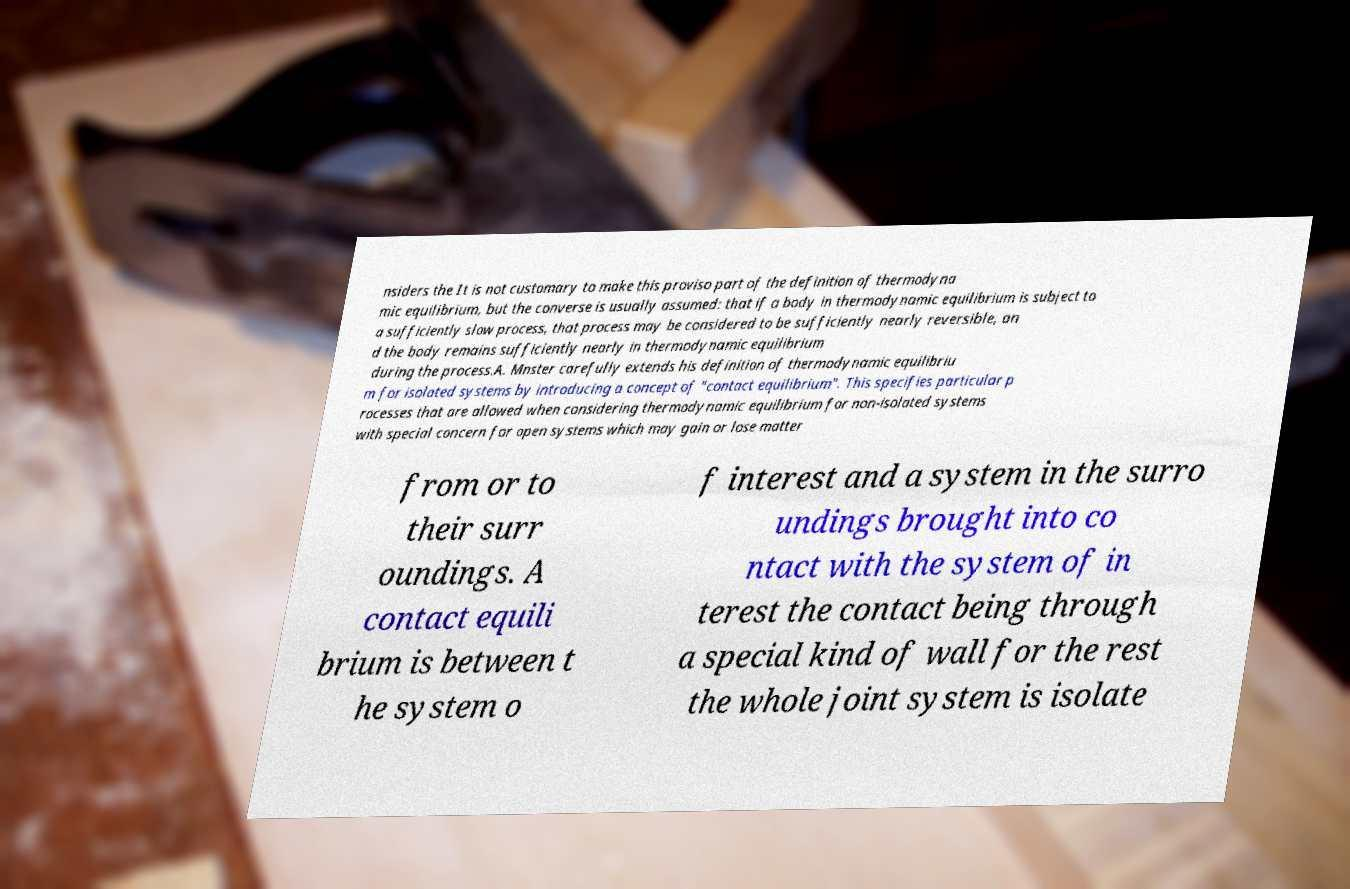There's text embedded in this image that I need extracted. Can you transcribe it verbatim? nsiders the It is not customary to make this proviso part of the definition of thermodyna mic equilibrium, but the converse is usually assumed: that if a body in thermodynamic equilibrium is subject to a sufficiently slow process, that process may be considered to be sufficiently nearly reversible, an d the body remains sufficiently nearly in thermodynamic equilibrium during the process.A. Mnster carefully extends his definition of thermodynamic equilibriu m for isolated systems by introducing a concept of "contact equilibrium". This specifies particular p rocesses that are allowed when considering thermodynamic equilibrium for non-isolated systems with special concern for open systems which may gain or lose matter from or to their surr oundings. A contact equili brium is between t he system o f interest and a system in the surro undings brought into co ntact with the system of in terest the contact being through a special kind of wall for the rest the whole joint system is isolate 